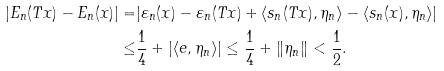<formula> <loc_0><loc_0><loc_500><loc_500>| E _ { n } ( T x ) - E _ { n } ( x ) | = & | \varepsilon _ { n } ( x ) - \varepsilon _ { n } ( T x ) + \langle s _ { n } ( T x ) , \eta _ { n } \rangle - \langle s _ { n } ( x ) , \eta _ { n } \rangle | \\ \leq & \frac { 1 } { 4 } + | \langle e , \eta _ { n } \rangle | \leq \frac { 1 } { 4 } + \| \eta _ { n } \| < \frac { 1 } { 2 } .</formula> 